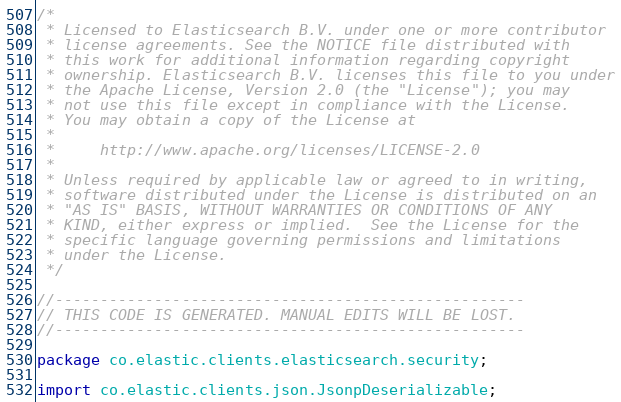<code> <loc_0><loc_0><loc_500><loc_500><_Java_>/*
 * Licensed to Elasticsearch B.V. under one or more contributor
 * license agreements. See the NOTICE file distributed with
 * this work for additional information regarding copyright
 * ownership. Elasticsearch B.V. licenses this file to you under
 * the Apache License, Version 2.0 (the "License"); you may
 * not use this file except in compliance with the License.
 * You may obtain a copy of the License at
 *
 *     http://www.apache.org/licenses/LICENSE-2.0
 *
 * Unless required by applicable law or agreed to in writing,
 * software distributed under the License is distributed on an
 * "AS IS" BASIS, WITHOUT WARRANTIES OR CONDITIONS OF ANY
 * KIND, either express or implied.  See the License for the
 * specific language governing permissions and limitations
 * under the License.
 */

//----------------------------------------------------
// THIS CODE IS GENERATED. MANUAL EDITS WILL BE LOST.
//----------------------------------------------------

package co.elastic.clients.elasticsearch.security;

import co.elastic.clients.json.JsonpDeserializable;</code> 